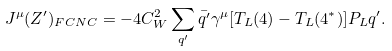Convert formula to latex. <formula><loc_0><loc_0><loc_500><loc_500>J ^ { \mu } ( Z ^ { \prime } ) _ { F C N C } = - 4 C ^ { 2 } _ { W } \sum _ { q ^ { \prime } } \bar { q ^ { \prime } } \gamma ^ { \mu } [ T _ { L } ( 4 ) - T _ { L } ( 4 ^ { * } ) ] P _ { L } q ^ { \prime } .</formula> 